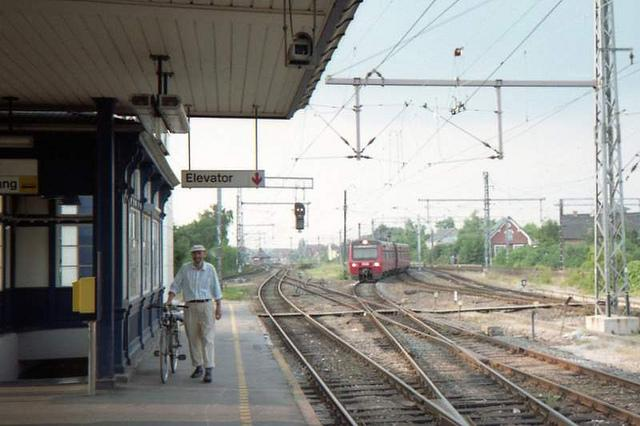What is the object hanging underneath the roof eave? sign 